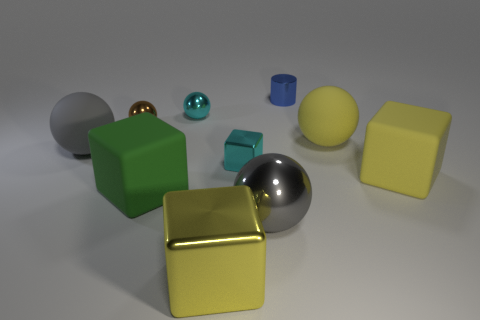There is a cylinder; are there any big gray shiny objects behind it? no 